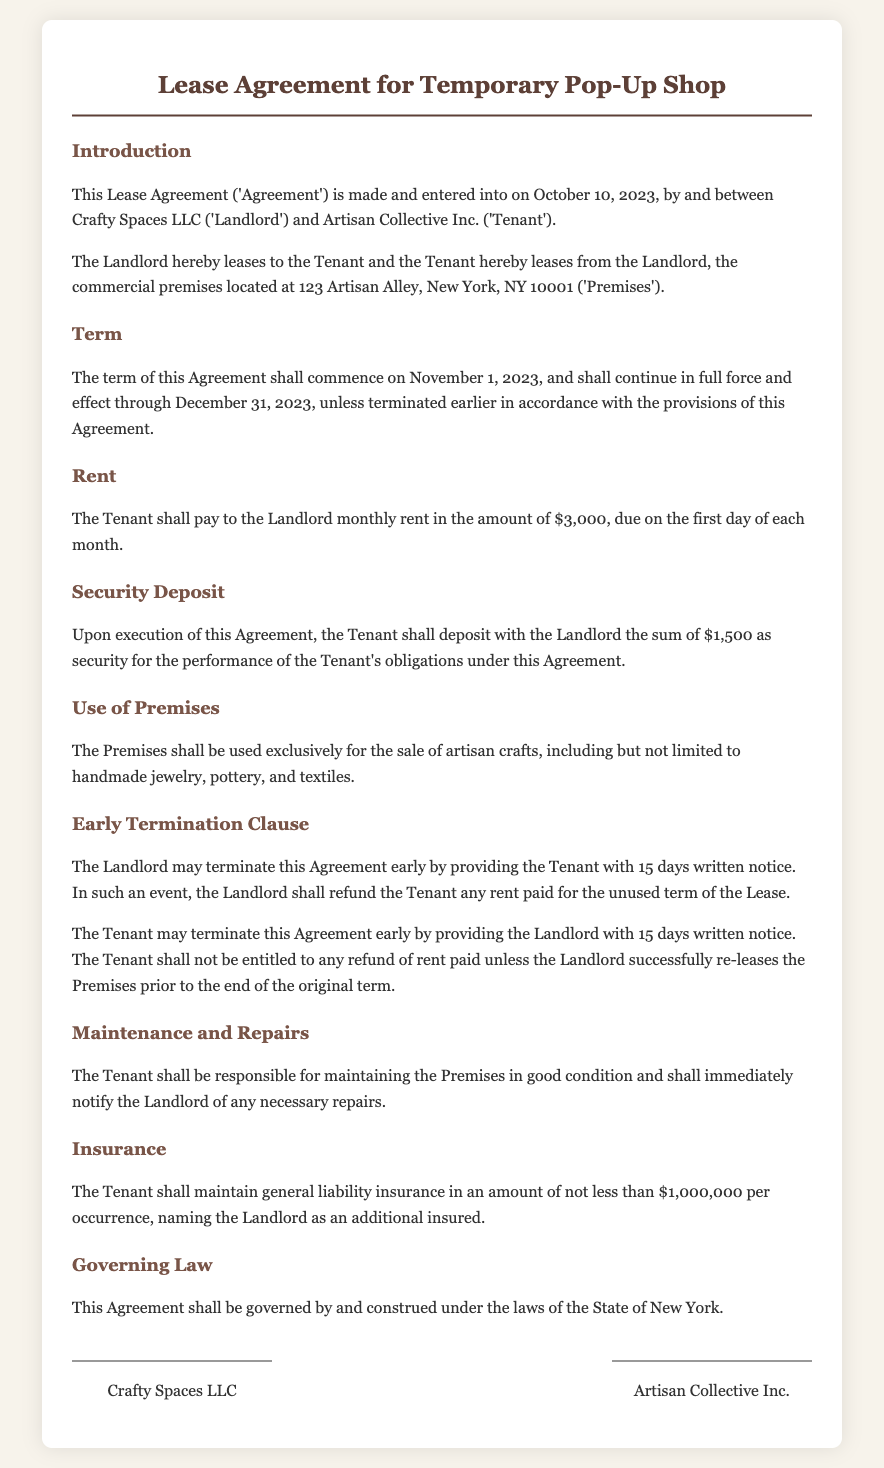What date does the lease commence? The lease commencement date is explicitly stated in the document as November 1, 2023.
Answer: November 1, 2023 What is the monthly rent amount? The document specifies the monthly rent that the Tenant is required to pay to the Landlord, which is $3,000.
Answer: $3,000 What is the security deposit amount? The document mentions the amount the Tenant must deposit as security, which is stated in the text as $1,500.
Answer: $1,500 How many days' notice must the Tenant give for early termination? The text outlines the notice period required for the Tenant's early termination, which is set at 15 days.
Answer: 15 days What can the Landlord do if they terminate the agreement early? The document states that upon early termination, the Landlord shall refund the Tenant any rent paid for the unused term of the Lease.
Answer: Refund rent paid What is the use of the Premises specified in the lease? The document specifies that the Premises shall be used exclusively for selling artisan crafts, detailing several examples.
Answer: Sale of artisan crafts What insurance coverage must the Tenant maintain? The document requires the Tenant to maintain general liability insurance of not less than $1,000,000 per occurrence.
Answer: $1,000,000 What is the governing law for the agreement? The document states that this Agreement shall be governed by the laws of the State of New York.
Answer: State of New York What type of agreement is this document? The document is a lease agreement specifically designed for a temporary pop-up shop.
Answer: Lease agreement 